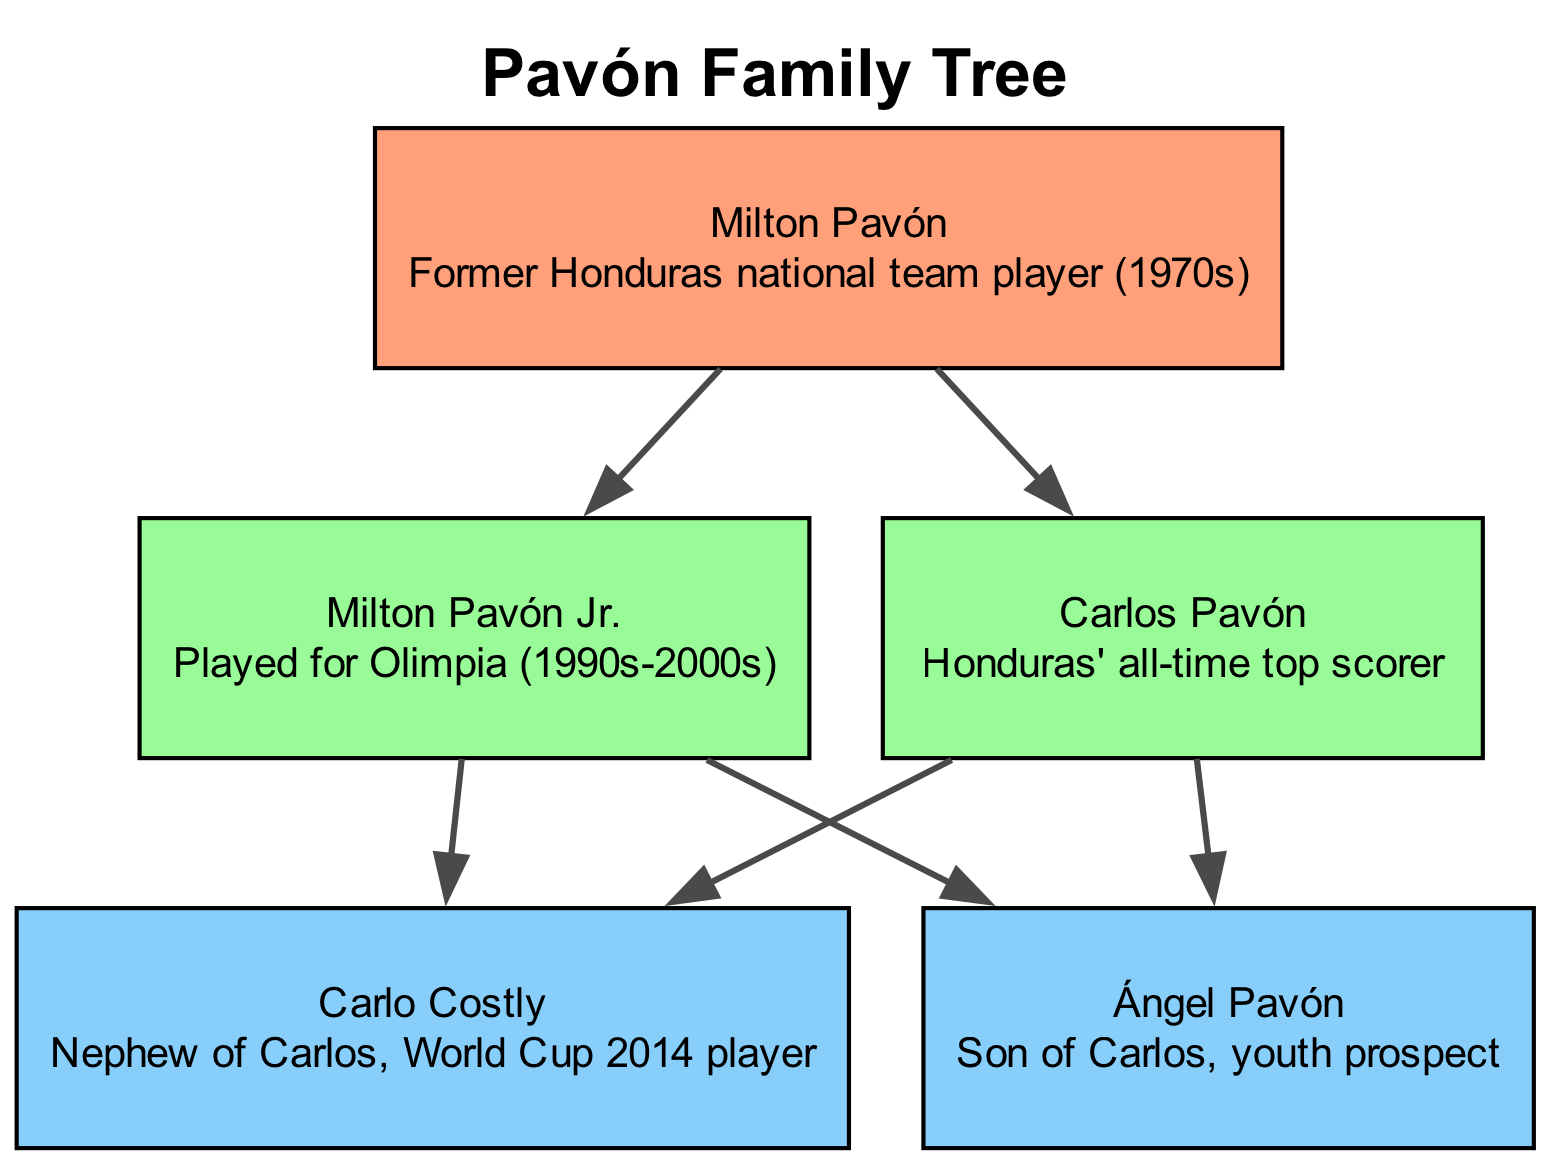What is the name of the first generation member? The first generation member is identified at the top level of the diagram, which contains only one member: Milton Pavón.
Answer: Milton Pavón Who is the all-time top scorer for Honduras? In the second generation, within the members listed, Carlos Pavón is specifically noted as Honduras' all-time top scorer.
Answer: Carlos Pavón How many generations are represented in the diagram? By counting the groups labeled by generations in the diagram, it is evident that there are three distinct generations represented.
Answer: 3 Who are the members of the third generation? The third generation node lists Carlo Costly and Ángel Pavón, who are connected as children of Carlos Pavón from the second generation.
Answer: Carlo Costly, Ángel Pavón Which member is a World Cup 2014 player? Within the third generation, the member identified as Carlo Costly has been explicitly mentioned as a player who participated in the 2014 World Cup, indicating his significance in this context.
Answer: Carlo Costly How many members are there in the second generation? The second generation shows two members, Milton Pavón Jr. and Carlos Pavón, making it straightforward to count and verify membership.
Answer: 2 What is the relationship between Ángel Pavón and Carlos Pavón? In the diagram, Ángel Pavón is clearly marked as a descendant of Carlos Pavón, identifying him as his son, illustrating a direct familial connection.
Answer: Son Which member is noted as a youth prospect? Among the third generation members noted in the diagram, Ángel Pavón is specifically labeled as a youth prospect, thereby highlighting his potential in football.
Answer: Ángel Pavón Who is the nephew of Carlos Pavón? Carlo Costly is identified in the diagram as being Carlos Pavón’s nephew, thus clarifying this family relationship amongst the listed members.
Answer: Carlo Costly 